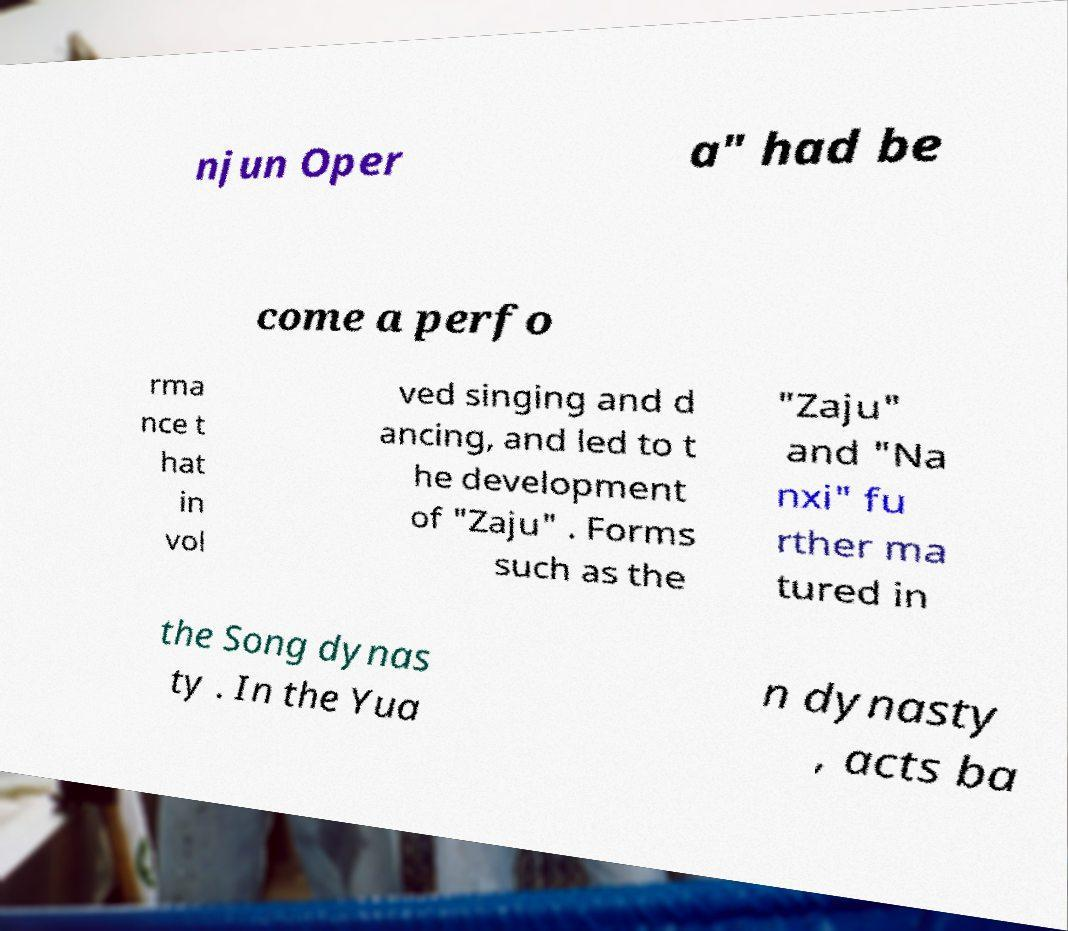Could you assist in decoding the text presented in this image and type it out clearly? njun Oper a" had be come a perfo rma nce t hat in vol ved singing and d ancing, and led to t he development of "Zaju" . Forms such as the "Zaju" and "Na nxi" fu rther ma tured in the Song dynas ty . In the Yua n dynasty , acts ba 